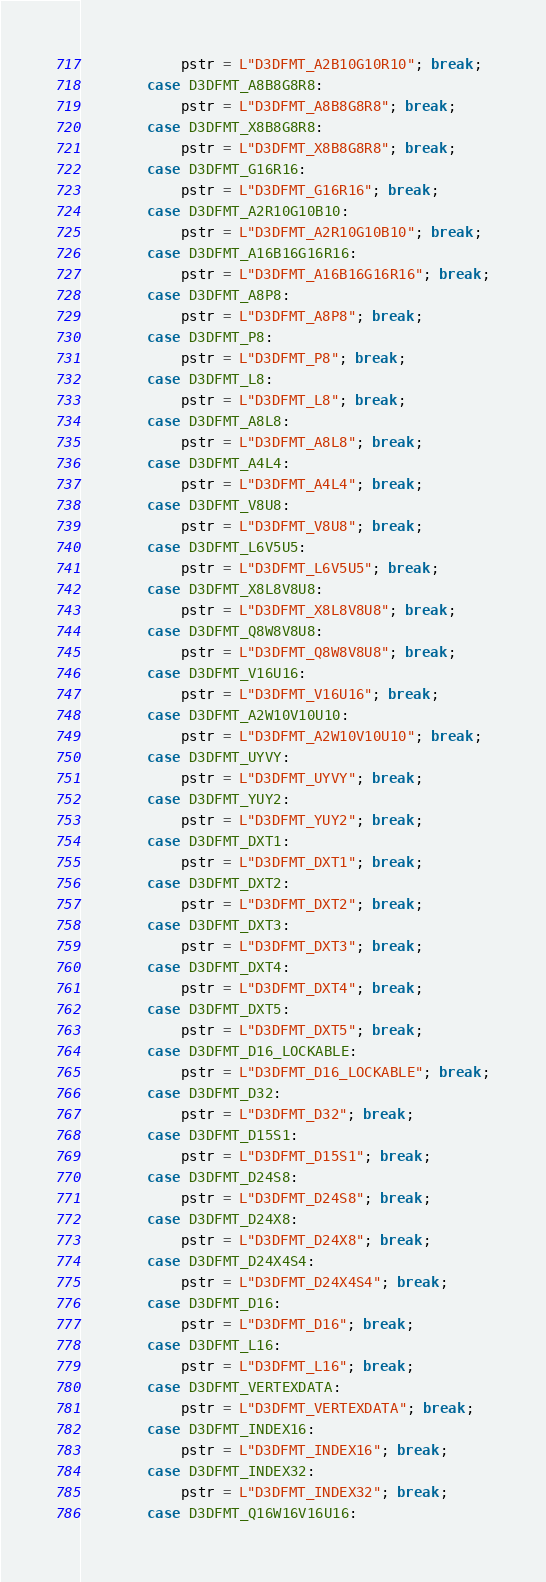Convert code to text. <code><loc_0><loc_0><loc_500><loc_500><_C++_>            pstr = L"D3DFMT_A2B10G10R10"; break;
        case D3DFMT_A8B8G8R8:
            pstr = L"D3DFMT_A8B8G8R8"; break;
        case D3DFMT_X8B8G8R8:
            pstr = L"D3DFMT_X8B8G8R8"; break;
        case D3DFMT_G16R16:
            pstr = L"D3DFMT_G16R16"; break;
        case D3DFMT_A2R10G10B10:
            pstr = L"D3DFMT_A2R10G10B10"; break;
        case D3DFMT_A16B16G16R16:
            pstr = L"D3DFMT_A16B16G16R16"; break;
        case D3DFMT_A8P8:
            pstr = L"D3DFMT_A8P8"; break;
        case D3DFMT_P8:
            pstr = L"D3DFMT_P8"; break;
        case D3DFMT_L8:
            pstr = L"D3DFMT_L8"; break;
        case D3DFMT_A8L8:
            pstr = L"D3DFMT_A8L8"; break;
        case D3DFMT_A4L4:
            pstr = L"D3DFMT_A4L4"; break;
        case D3DFMT_V8U8:
            pstr = L"D3DFMT_V8U8"; break;
        case D3DFMT_L6V5U5:
            pstr = L"D3DFMT_L6V5U5"; break;
        case D3DFMT_X8L8V8U8:
            pstr = L"D3DFMT_X8L8V8U8"; break;
        case D3DFMT_Q8W8V8U8:
            pstr = L"D3DFMT_Q8W8V8U8"; break;
        case D3DFMT_V16U16:
            pstr = L"D3DFMT_V16U16"; break;
        case D3DFMT_A2W10V10U10:
            pstr = L"D3DFMT_A2W10V10U10"; break;
        case D3DFMT_UYVY:
            pstr = L"D3DFMT_UYVY"; break;
        case D3DFMT_YUY2:
            pstr = L"D3DFMT_YUY2"; break;
        case D3DFMT_DXT1:
            pstr = L"D3DFMT_DXT1"; break;
        case D3DFMT_DXT2:
            pstr = L"D3DFMT_DXT2"; break;
        case D3DFMT_DXT3:
            pstr = L"D3DFMT_DXT3"; break;
        case D3DFMT_DXT4:
            pstr = L"D3DFMT_DXT4"; break;
        case D3DFMT_DXT5:
            pstr = L"D3DFMT_DXT5"; break;
        case D3DFMT_D16_LOCKABLE:
            pstr = L"D3DFMT_D16_LOCKABLE"; break;
        case D3DFMT_D32:
            pstr = L"D3DFMT_D32"; break;
        case D3DFMT_D15S1:
            pstr = L"D3DFMT_D15S1"; break;
        case D3DFMT_D24S8:
            pstr = L"D3DFMT_D24S8"; break;
        case D3DFMT_D24X8:
            pstr = L"D3DFMT_D24X8"; break;
        case D3DFMT_D24X4S4:
            pstr = L"D3DFMT_D24X4S4"; break;
        case D3DFMT_D16:
            pstr = L"D3DFMT_D16"; break;
        case D3DFMT_L16:
            pstr = L"D3DFMT_L16"; break;
        case D3DFMT_VERTEXDATA:
            pstr = L"D3DFMT_VERTEXDATA"; break;
        case D3DFMT_INDEX16:
            pstr = L"D3DFMT_INDEX16"; break;
        case D3DFMT_INDEX32:
            pstr = L"D3DFMT_INDEX32"; break;
        case D3DFMT_Q16W16V16U16:</code> 